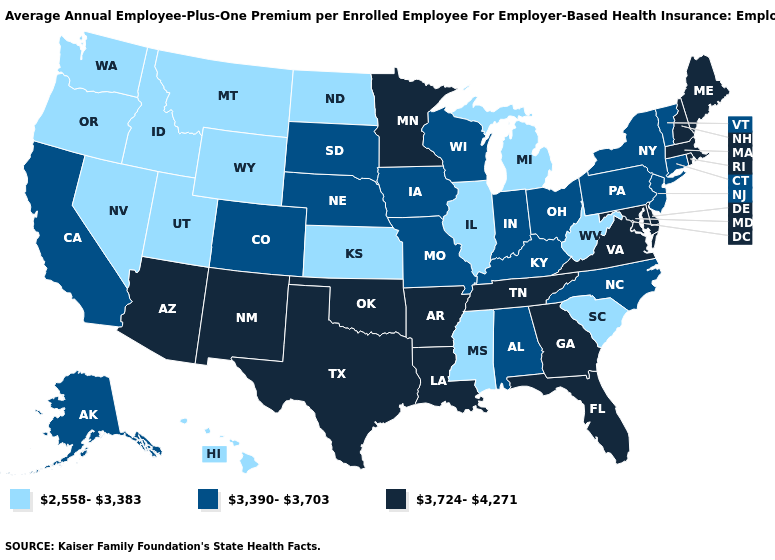What is the value of Hawaii?
Concise answer only. 2,558-3,383. Name the states that have a value in the range 2,558-3,383?
Keep it brief. Hawaii, Idaho, Illinois, Kansas, Michigan, Mississippi, Montana, Nevada, North Dakota, Oregon, South Carolina, Utah, Washington, West Virginia, Wyoming. Among the states that border North Dakota , does Minnesota have the highest value?
Keep it brief. Yes. Does the first symbol in the legend represent the smallest category?
Concise answer only. Yes. What is the highest value in states that border West Virginia?
Concise answer only. 3,724-4,271. What is the value of Georgia?
Concise answer only. 3,724-4,271. Among the states that border New York , which have the highest value?
Quick response, please. Massachusetts. Does South Carolina have a lower value than Delaware?
Quick response, please. Yes. Does the map have missing data?
Short answer required. No. Does Massachusetts have the same value as Texas?
Answer briefly. Yes. Does Indiana have the highest value in the MidWest?
Short answer required. No. Does the map have missing data?
Give a very brief answer. No. Which states have the lowest value in the USA?
Be succinct. Hawaii, Idaho, Illinois, Kansas, Michigan, Mississippi, Montana, Nevada, North Dakota, Oregon, South Carolina, Utah, Washington, West Virginia, Wyoming. What is the value of Alabama?
Give a very brief answer. 3,390-3,703. What is the highest value in the Northeast ?
Be succinct. 3,724-4,271. 